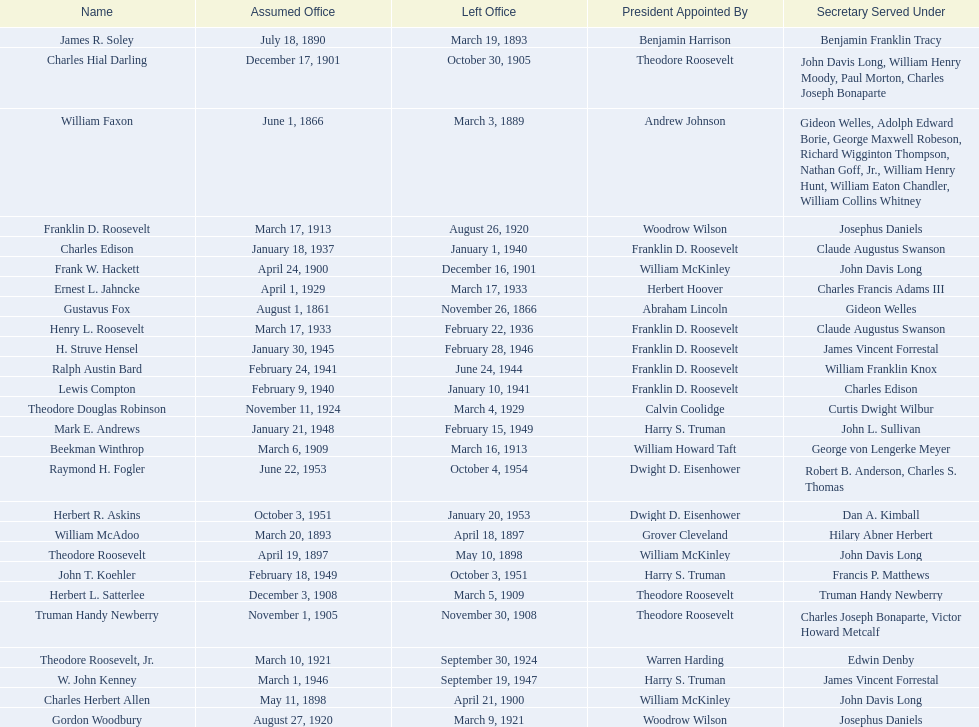Who are all of the assistant secretaries of the navy in the 20th century? Charles Herbert Allen, Frank W. Hackett, Charles Hial Darling, Truman Handy Newberry, Herbert L. Satterlee, Beekman Winthrop, Franklin D. Roosevelt, Gordon Woodbury, Theodore Roosevelt, Jr., Theodore Douglas Robinson, Ernest L. Jahncke, Henry L. Roosevelt, Charles Edison, Lewis Compton, Ralph Austin Bard, H. Struve Hensel, W. John Kenney, Mark E. Andrews, John T. Koehler, Herbert R. Askins, Raymond H. Fogler. What date was assistant secretary of the navy raymond h. fogler appointed? June 22, 1953. What date did assistant secretary of the navy raymond h. fogler leave office? October 4, 1954. 